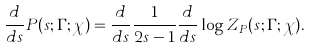Convert formula to latex. <formula><loc_0><loc_0><loc_500><loc_500>\frac { d } { d s } P ( s ; \Gamma ; \chi ) = \frac { d } { d s } \frac { 1 } { 2 s - 1 } \frac { d } { d s } \log Z _ { P } ( s ; \Gamma ; \chi ) .</formula> 